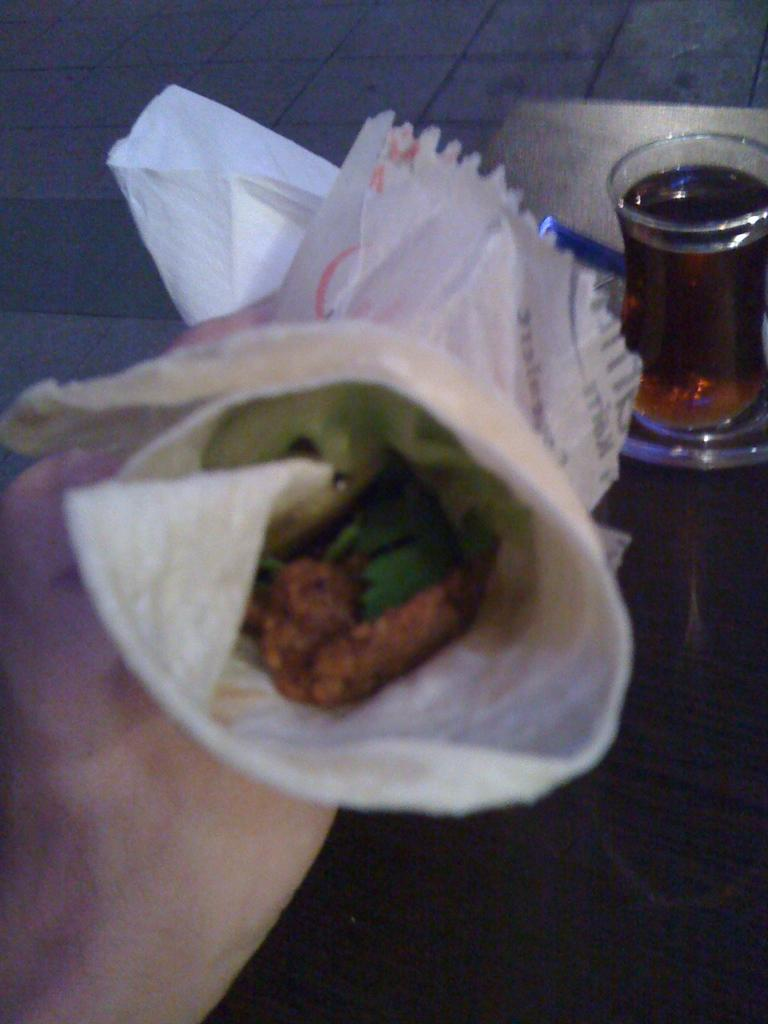What is the main subject of the image? There is a person in the image. What is the person holding in the image? The person is holding a food roll wrapped in a paper napkin. Can you describe any other objects in the image? There is a glass tumbler with a beverage in the image. What language is the person speaking in the image? There is no indication of the person speaking in the image, so it cannot be determined what language they might be using. 